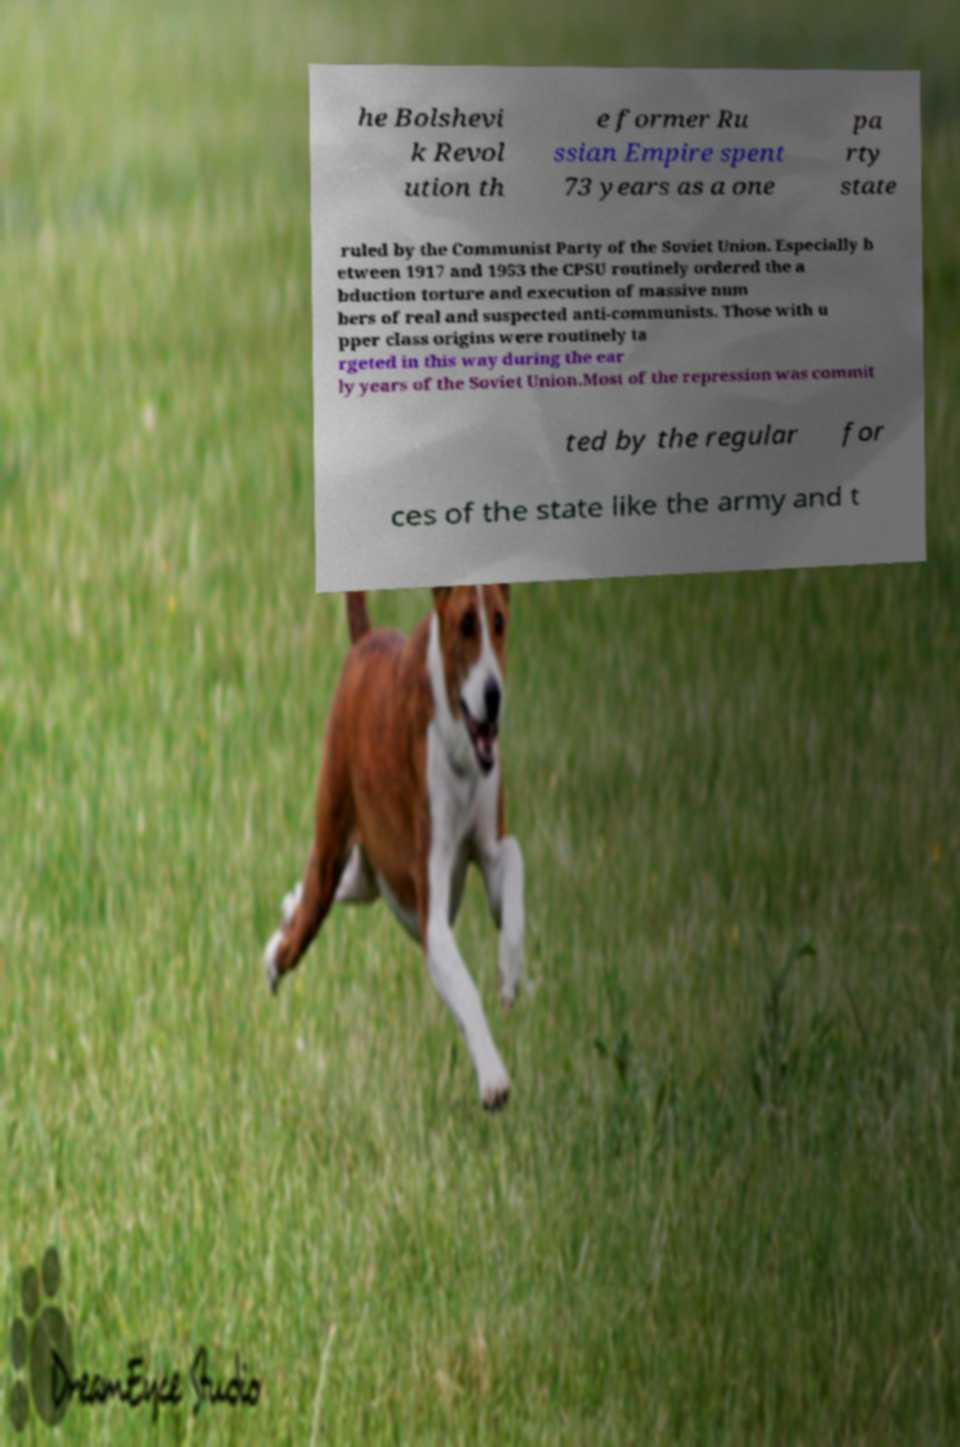Can you accurately transcribe the text from the provided image for me? he Bolshevi k Revol ution th e former Ru ssian Empire spent 73 years as a one pa rty state ruled by the Communist Party of the Soviet Union. Especially b etween 1917 and 1953 the CPSU routinely ordered the a bduction torture and execution of massive num bers of real and suspected anti-communists. Those with u pper class origins were routinely ta rgeted in this way during the ear ly years of the Soviet Union.Most of the repression was commit ted by the regular for ces of the state like the army and t 